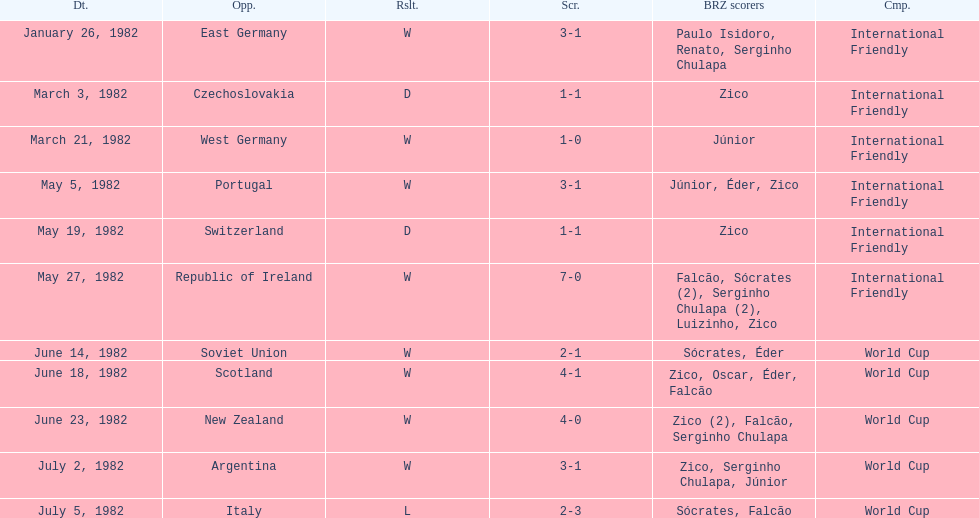Was the total goals scored on june 14, 1982 more than 6? No. 